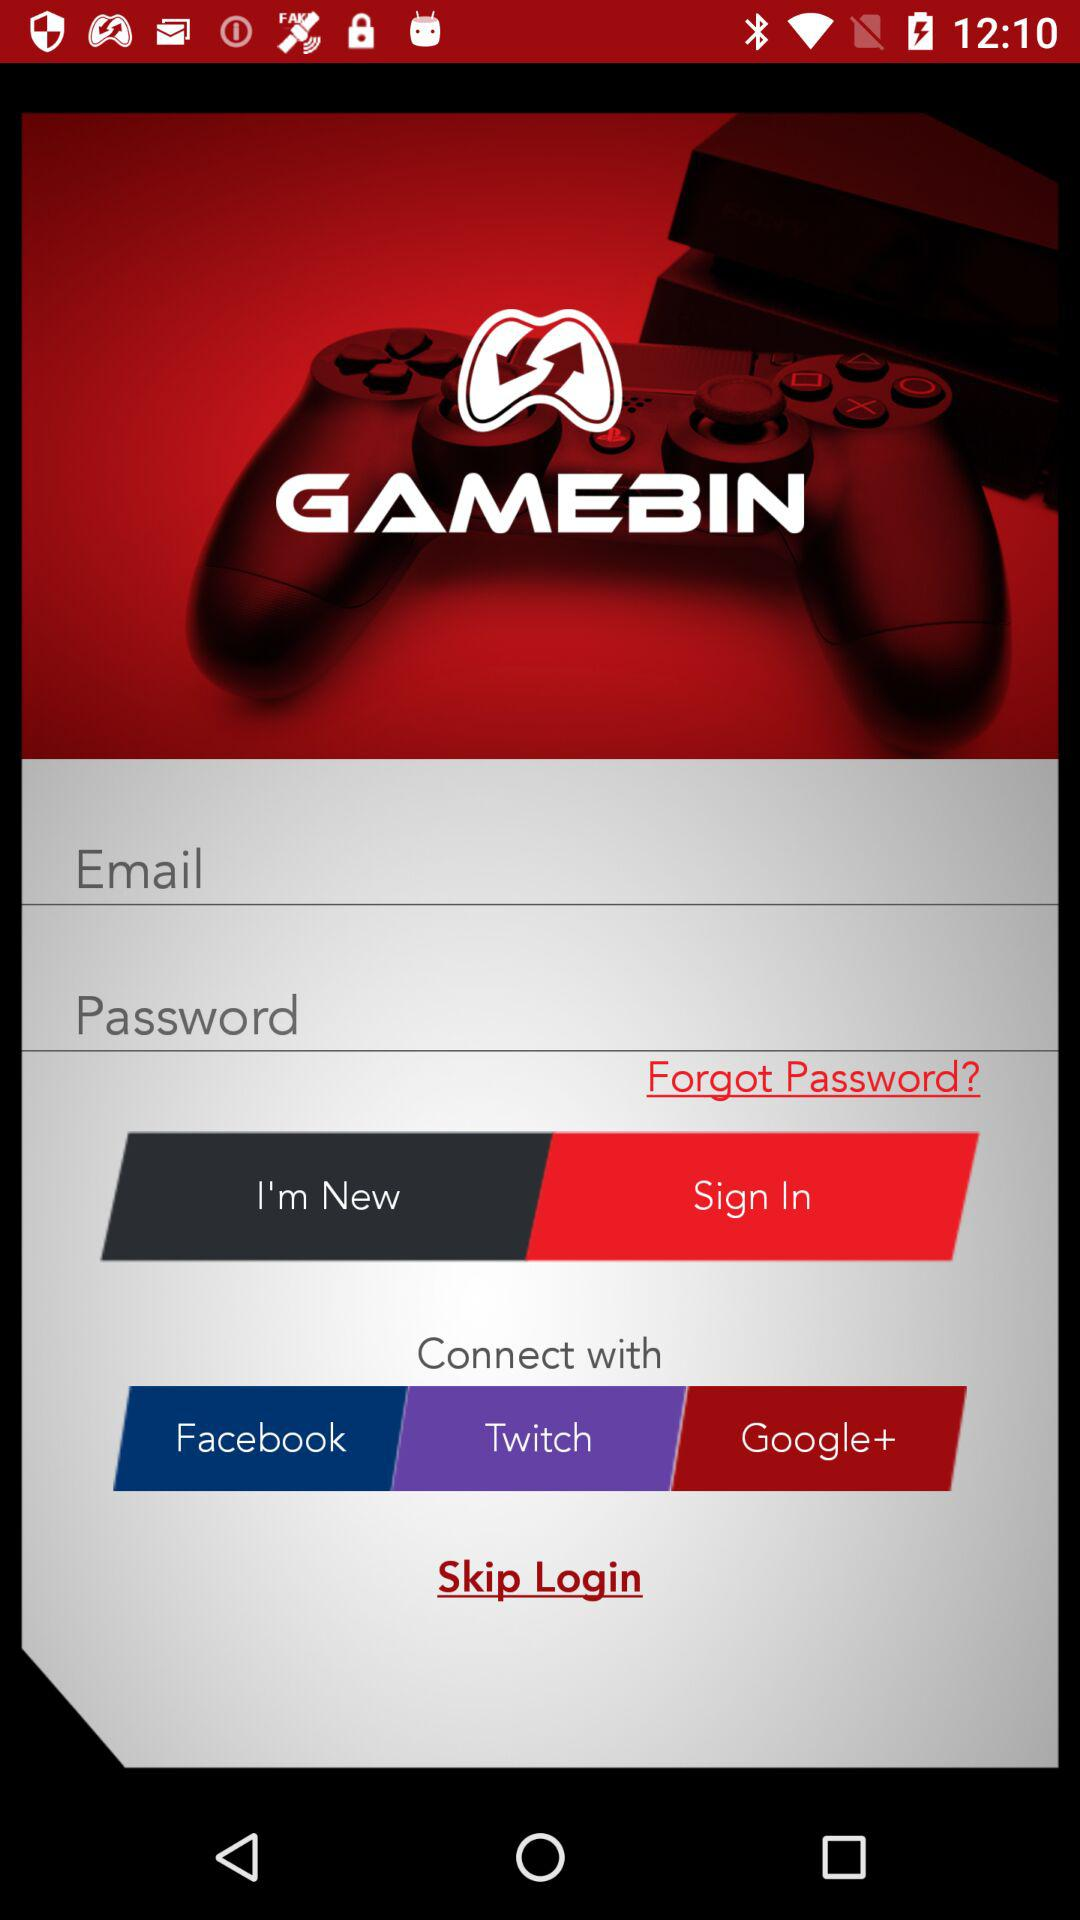How many social media platforms can I connect with?
Answer the question using a single word or phrase. 3 